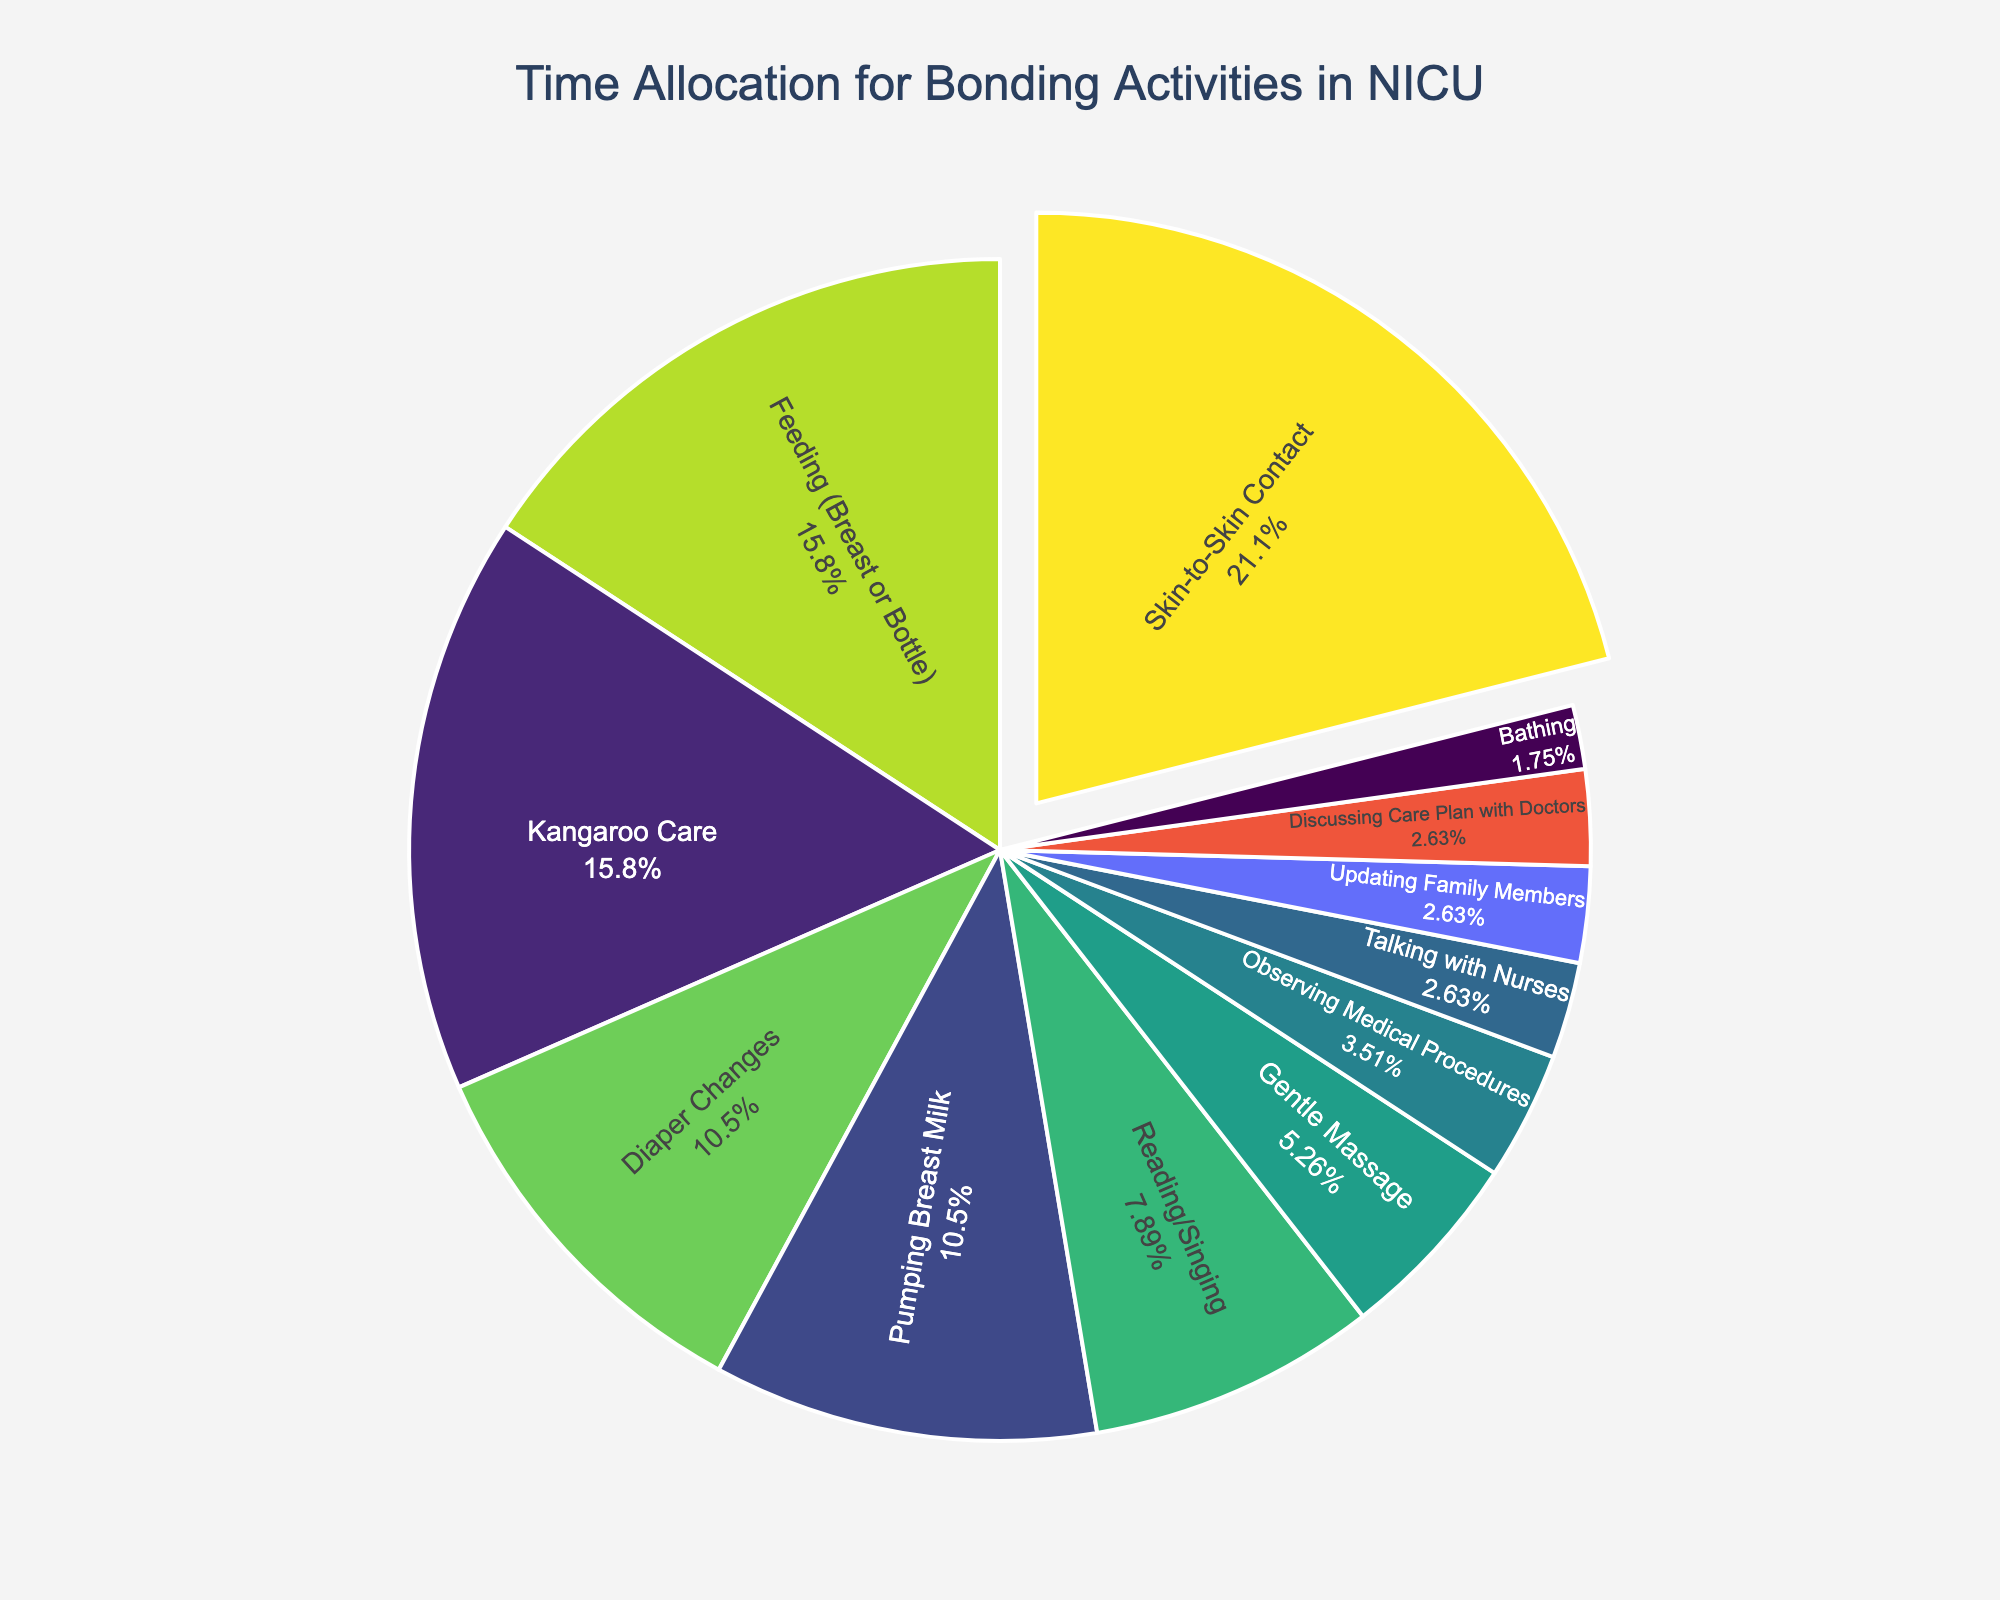What's the most time-consuming bonding activity? By referring to the pie chart, you can see which segment is the largest. The largest segment represents the activity with the highest minutes per day.
Answer: Skin-to-Skin Contact Which activities take up exactly 90 minutes per day? Look at the segments of the pie chart that correspond to activities and their respective time allocations. Identify the segments that show 90 minutes per day.
Answer: Feeding (Breast or Bottle) and Kangaroo Care Which activity has the smallest slice in the pie chart? Observe the pie chart and identify the smallest segment, which represents the activity with the fewest minutes per day.
Answer: Bathing How much time is spent on Reading/Singing and Gentle Massage combined? Find the segments for Reading/Singing (45 minutes) and Gentle Massage (30 minutes), then sum these values. 45 + 30 = 75 minutes.
Answer: 75 minutes Is more time spent on Feeding or Pumping Breast Milk? Compare the sizes of the pie chart segments for Feeding (90 minutes) and Pumping Breast Milk (60 minutes).
Answer: Feeding What percentage of the day is spent on Kangaroo Care? Look at the percentage displayed inside the segment for Kangaroo Care. It is calculated as (90 minutes / total minutes) * 100.
Answer: 13.8% How much less time is allocated to Bathing compared to Diaper Changes? Subtract the minutes for Bathing (10 minutes) from the minutes for Diaper Changes (60 minutes). 60 - 10 = 50 minutes.
Answer: 50 minutes How is the pie chart visually designed to highlight Skin-to-Skin Contact? The chart's Skin-to-Skin Contact segment is pulled out slightly from the main pie to draw attention to it.
Answer: It's pulled out What activities are allocated 15 minutes each? Look at the segments that represent 15 minutes each. There are segments for Updating Family Members, Talking with Nurses, and Discussing Care Plan with Doctors.
Answer: Updating Family Members, Talking with Nurses, Discussing Care Plan with Doctors What color is typically associated with the segment for Pumping Breast Milk? Observe the color scheme used in the pie chart. The colors usually range from blue to green to yellow in the Viridis color scale. Find the color for the Pumping Breast Milk segment.
Answer: Blue 